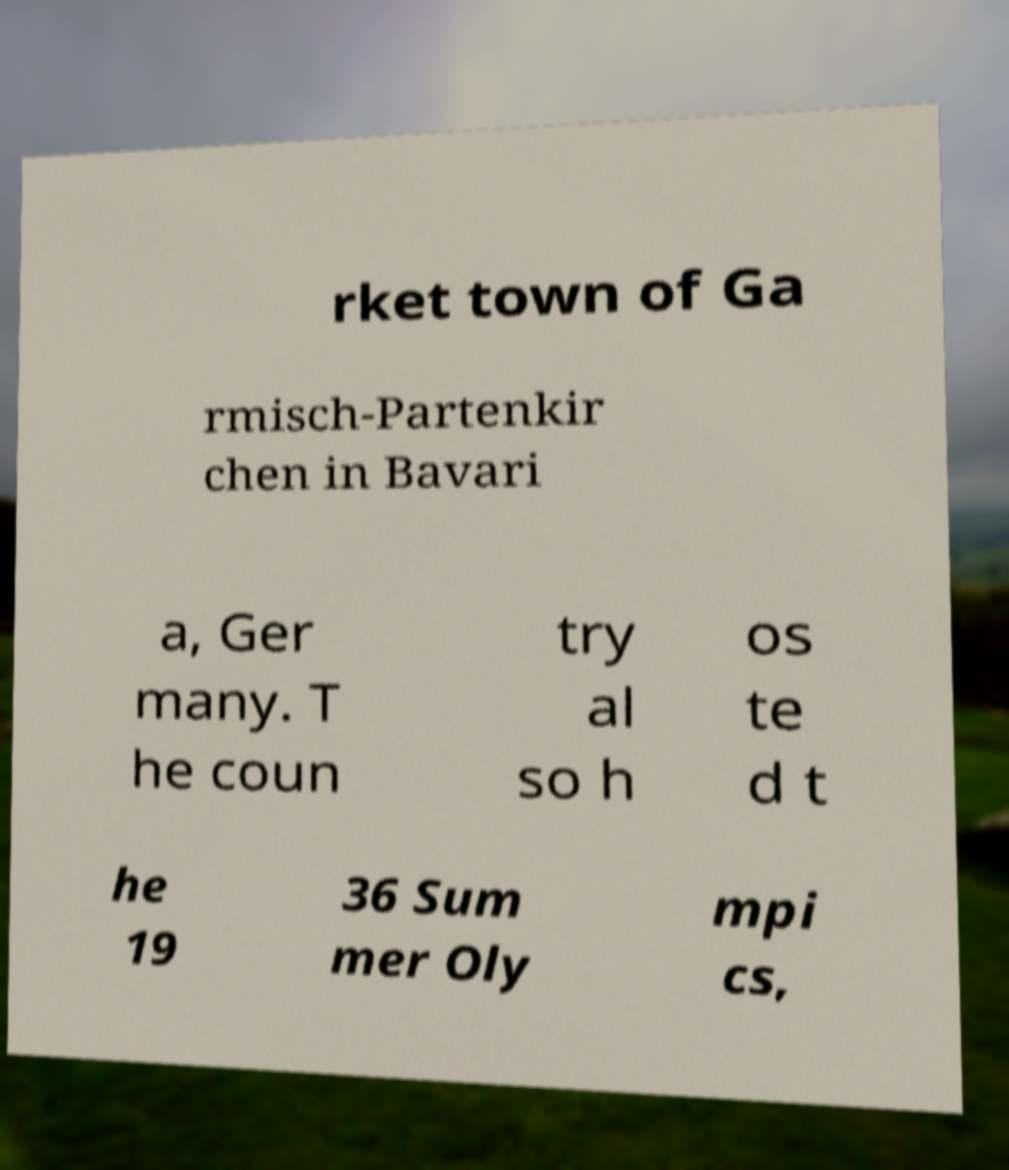What messages or text are displayed in this image? I need them in a readable, typed format. rket town of Ga rmisch-Partenkir chen in Bavari a, Ger many. T he coun try al so h os te d t he 19 36 Sum mer Oly mpi cs, 